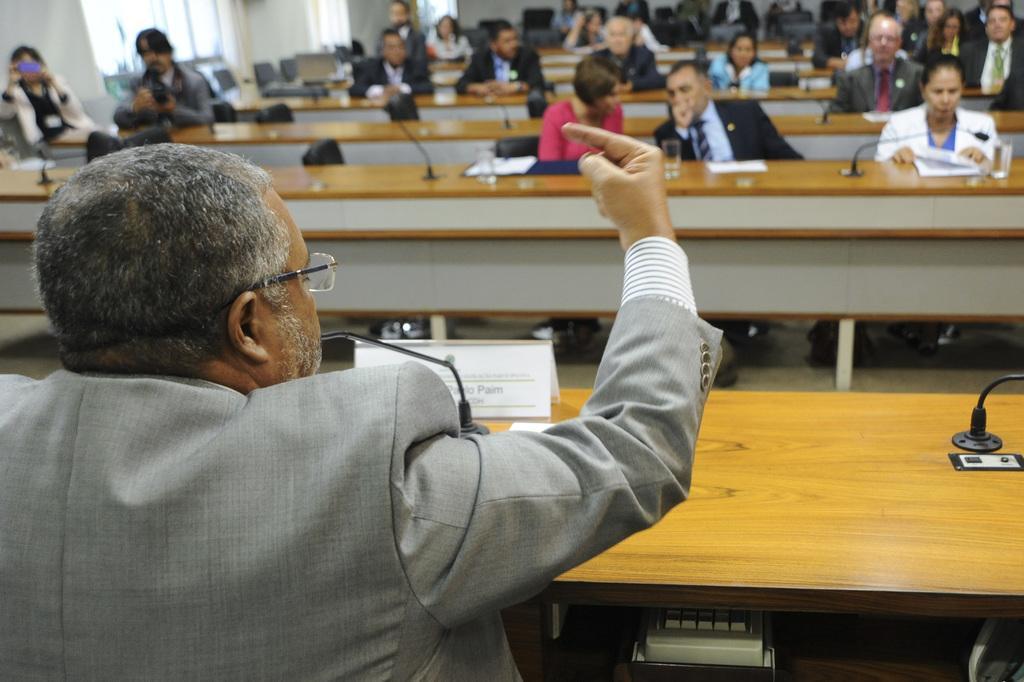Describe this image in one or two sentences. There is a man here. In front of him there are few people sitting on the chair ta their tables and listening to him. On the table we can see microphones,books and glass of water. 